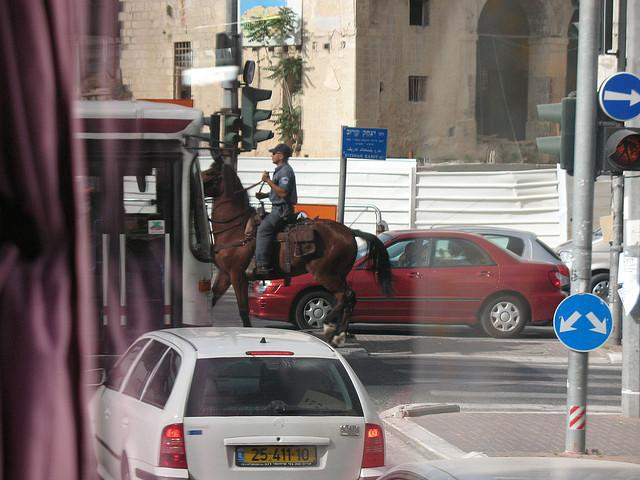What model is the red car?

Choices:
A) hatchback
B) sedan
C) station wagon
D) coupe sedan 